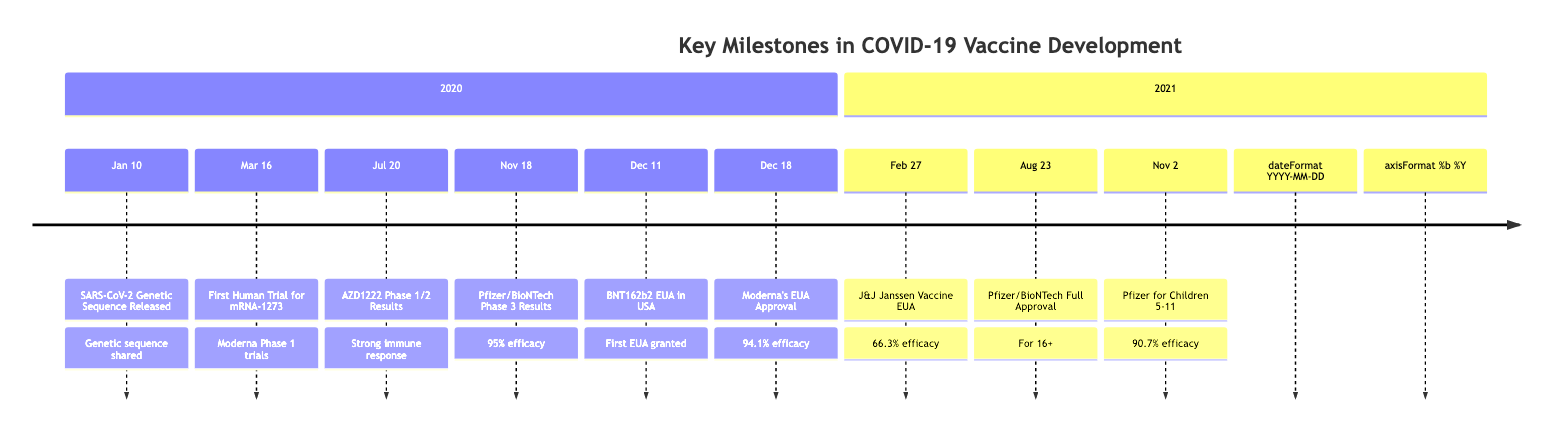What event occurred on January 10, 2020? The diagram indicates that on January 10, 2020, the event was the "Release of the SARS-CoV-2 Genetic Sequence," which is described as China sharing the genetic sequence that allowed for the initiation of vaccine research.
Answer: Release of the SARS-CoV-2 Genetic Sequence How many vaccines received Emergency Use Authorization (EUA) in 2020? The diagram displays that two vaccines received EUA in 2020: the Pfizer/BioNTech BNT162b2 on December 11 and Moderna's mRNA-1273 on December 18. Therefore, counting these two events gives us the answer.
Answer: 2 What was the efficacy of the Pfizer/BioNTech vaccine in its Phase 3 trials? Referring to the timeline, the Pfizer/BioNTech vaccine was announced to have 95% efficacy in Phase 3 trials on November 18, 2020.
Answer: 95% Which vaccine had the least efficacy among the listed COVID-19 vaccines? Looking through the data, Johnson & Johnson's Janssen vaccine had an efficacy of 66.3% as listed on February 27, 2021, which is lower than the other efficacy rates mentioned.
Answer: 66.3% What milestone occurred on August 23, 2021? According to the timeline, on August 23, 2021, the FDA granted full approval to Pfizer/BioNTech's BNT162b2 (Comirnaty) for individuals aged 16 and older, indicating a significant milestone in vaccine deployment.
Answer: First Full Approval What was the efficacy of the vaccine for children aged 5-11? The timeline notes that on November 2, 2021, the Pfizer/BioNTech vaccine had a reported efficacy of 90.7% in preventing COVID-19 in children aged 5-11, which addresses the question directly.
Answer: 90.7% When did the first human trial for an mRNA vaccine begin? The timeline states that the first human trial for mRNA-1273, an mRNA vaccine candidate by Moderna, began on March 16, 2020. This indicates the initiation of human trials for mRNA vaccines.
Answer: March 16, 2020 How many significant milestones occurred in 2020? By counting the events listed for the year 2020 on the timeline, we identify six significant milestones: January 10, March 16, July 20, November 18, December 11, and December 18. Therefore, the total count of these events gives us the answer.
Answer: 6 